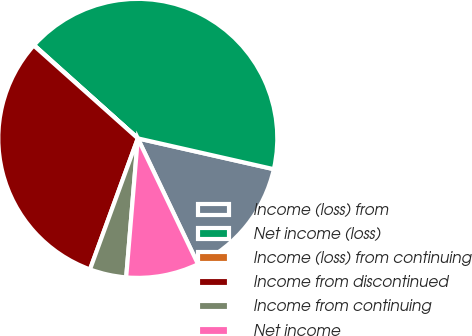Convert chart. <chart><loc_0><loc_0><loc_500><loc_500><pie_chart><fcel>Income (loss) from<fcel>Net income (loss)<fcel>Income (loss) from continuing<fcel>Income from discontinued<fcel>Income from continuing<fcel>Net income<nl><fcel>14.35%<fcel>41.89%<fcel>0.06%<fcel>31.02%<fcel>4.24%<fcel>8.43%<nl></chart> 